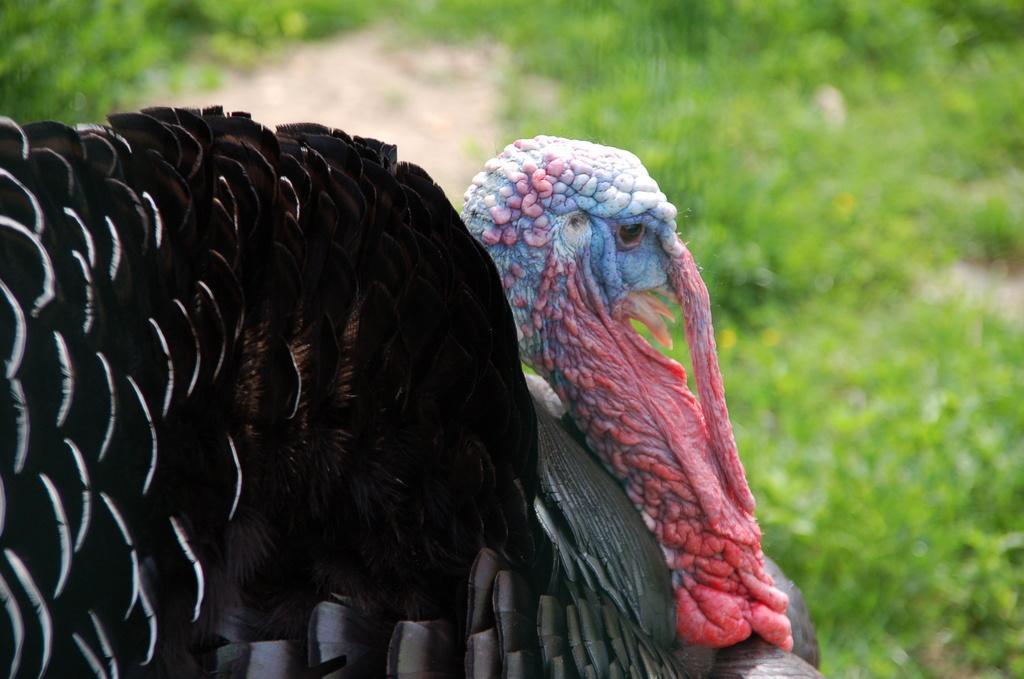Please provide a concise description of this image. In this picture we can see a turkey bird in the front, in the background there are some plants, we can see a blurry background. 